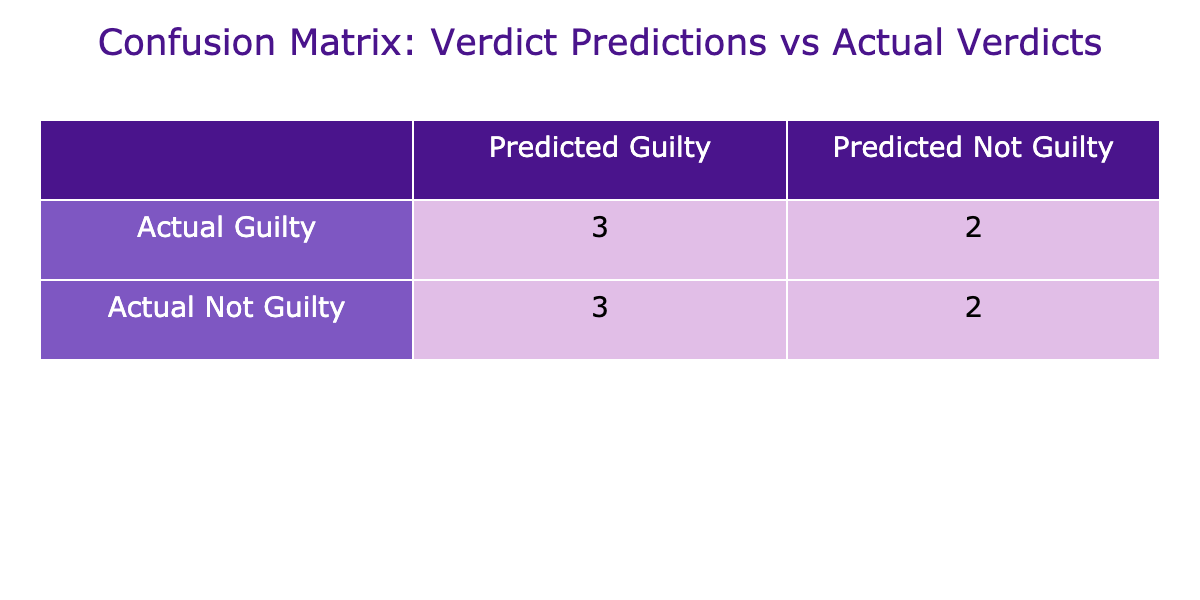What is the number of true positives in the table? True positives are instances where the predicted verdict is guilty and the actual verdict is also guilty. Referring to the table, "State vs. B. R. Ambedkar," "State vs. N. R. Narayana Murthy," and "State vs. 2G Spectrum Case" have both predicted and actual verdicts as guilty. Therefore, the total is 3 true positives.
Answer: 3 What is the number of false negatives in the table? False negatives occur when the predicted verdict is not guilty but the actual verdict is guilty. Looking at the table, "State vs. Jayalalithaa" and "State vs. Rajiv Gandhi Assassination" show this condition. Thus, the total number of false negatives is 2.
Answer: 2 Is there any instance of true negatives in the table? True negatives occur when both the predicted and actual verdicts are not guilty. According to the table, this is true for "State vs. Sanjay Dutt" and "State vs. Indrani Mukerjea." Therefore, there are true negatives present in the data.
Answer: Yes Which case has a false positive outcome? A false positive arises when the predicted verdict is guilty and the actual verdict is not guilty. Referring to the table, "State vs. Salman Khan" and "State vs. Vikas Dubey" meet this criterion. Thus, there are two cases listed with false positives.
Answer: Two What is the total number of cases that had actual verdicts of guilty? To understand this, we need to count the cases where the actual verdict is guilty. By examining the table, we see that "State vs. B. R. Ambedkar," "State vs. Jayalalithaa," "State vs. Rajiv Gandhi Assassination," and "State vs. Sheena Bora" are guilty cases. This results in a total of 4 cases with actual guilty verdicts.
Answer: 4 What is the difference between the number of predicted guilty and predicted not guilty cases? We begin by counting predicted guilty cases, which are 5 ("State vs. B. R. Ambedkar," "State vs. Salman Khan," "State vs. N. R. Narayana Murthy," "State vs. 2G Spectrum Case," and "State vs. Vikas Dubey"). There are 5 predicted guilty cases. The number of predicted not guilty cases is 5 ("State vs. Jayalalithaa," "State vs. Sanjay Dutt," "State vs. Indrani Mukerjea," and "State vs. Sheena Bora"). Thus, the difference is 5 - 5 = 0.
Answer: 0 Are there more instances of incorrect predictions than correct predictions? To find this, we aggregate the counts of incorrect predictions, which consist of false positives and false negatives (2 false negatives + 2 false positives = 4 incorrect predictions). Correct predictions include true positives and true negatives (3 true positives + 2 true negatives = 5 correct predictions). Since 4 is less than 5, there are more correct predictions than incorrect.
Answer: No Which case title had the highest number of discrepancies between predicted and actual verdicts? Discrepancies can be identified by comparing cases where the predicted and actual verdicts differ. The cases "State vs. Jayalalithaa," "State vs. Salman Khan," and "State vs. Vikas Dubey" all show discrepancies. However, no single case title stands out as having the highest frequency since they all share one discrepancy each, indicating equal discrepancy count.
Answer: Equal discrepancies across cases 